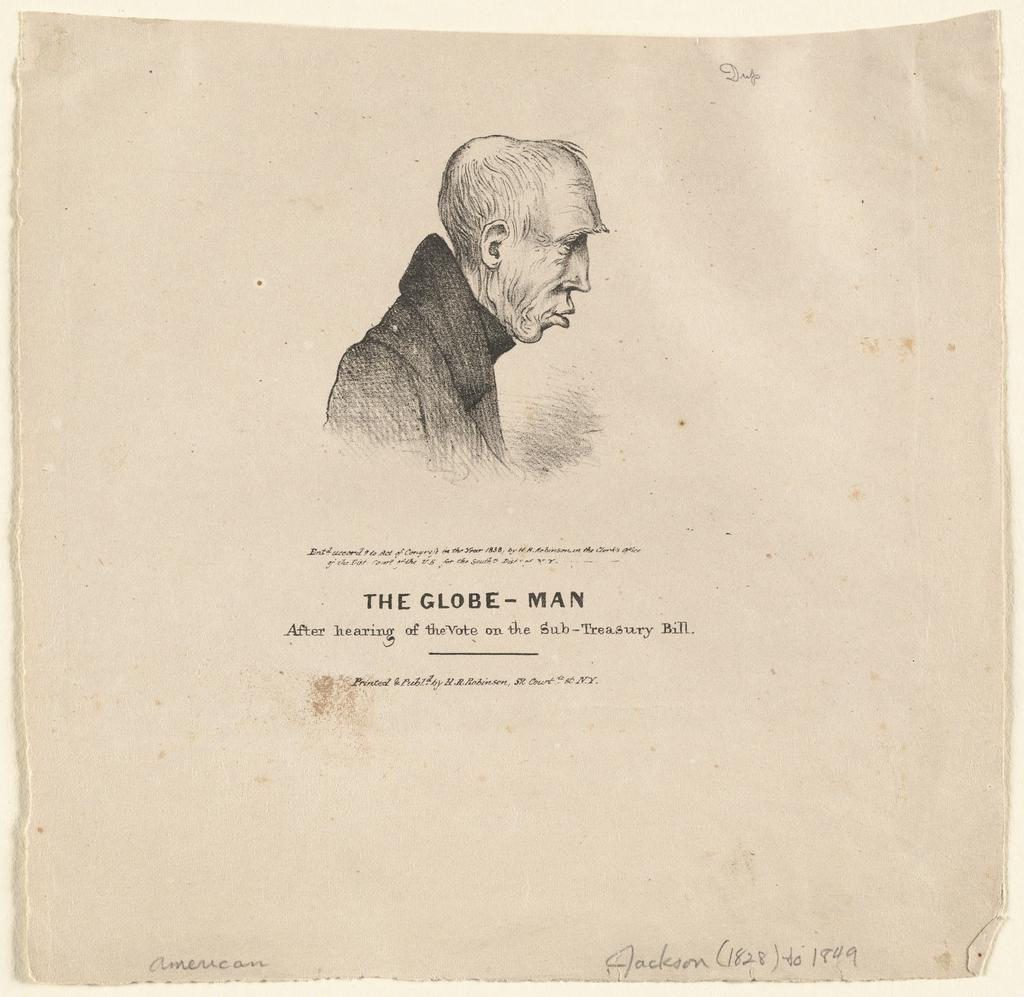What is present in the image? There is a poster in the image. What is depicted on the poster? The poster contains a person. What else is featured on the poster besides the person? The poster contains text. What type of powder is being used by the person on the poster? There is no powder visible in the image, as it only features a poster with a person and text. 